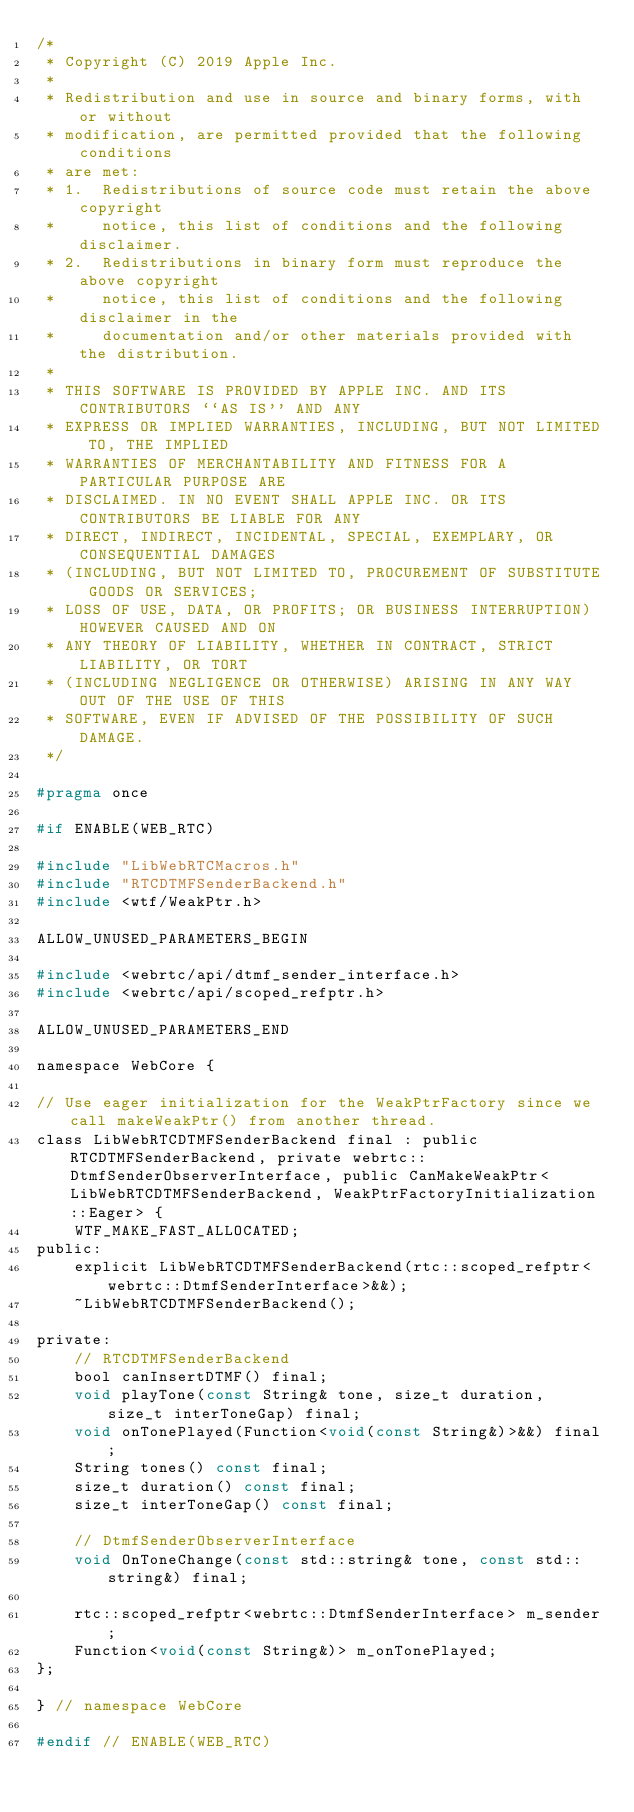<code> <loc_0><loc_0><loc_500><loc_500><_C_>/*
 * Copyright (C) 2019 Apple Inc.
 *
 * Redistribution and use in source and binary forms, with or without
 * modification, are permitted provided that the following conditions
 * are met:
 * 1.  Redistributions of source code must retain the above copyright
 *     notice, this list of conditions and the following disclaimer.
 * 2.  Redistributions in binary form must reproduce the above copyright
 *     notice, this list of conditions and the following disclaimer in the
 *     documentation and/or other materials provided with the distribution.
 *
 * THIS SOFTWARE IS PROVIDED BY APPLE INC. AND ITS CONTRIBUTORS ``AS IS'' AND ANY
 * EXPRESS OR IMPLIED WARRANTIES, INCLUDING, BUT NOT LIMITED TO, THE IMPLIED
 * WARRANTIES OF MERCHANTABILITY AND FITNESS FOR A PARTICULAR PURPOSE ARE
 * DISCLAIMED. IN NO EVENT SHALL APPLE INC. OR ITS CONTRIBUTORS BE LIABLE FOR ANY
 * DIRECT, INDIRECT, INCIDENTAL, SPECIAL, EXEMPLARY, OR CONSEQUENTIAL DAMAGES
 * (INCLUDING, BUT NOT LIMITED TO, PROCUREMENT OF SUBSTITUTE GOODS OR SERVICES;
 * LOSS OF USE, DATA, OR PROFITS; OR BUSINESS INTERRUPTION) HOWEVER CAUSED AND ON
 * ANY THEORY OF LIABILITY, WHETHER IN CONTRACT, STRICT LIABILITY, OR TORT
 * (INCLUDING NEGLIGENCE OR OTHERWISE) ARISING IN ANY WAY OUT OF THE USE OF THIS
 * SOFTWARE, EVEN IF ADVISED OF THE POSSIBILITY OF SUCH DAMAGE.
 */

#pragma once

#if ENABLE(WEB_RTC)

#include "LibWebRTCMacros.h"
#include "RTCDTMFSenderBackend.h"
#include <wtf/WeakPtr.h>

ALLOW_UNUSED_PARAMETERS_BEGIN

#include <webrtc/api/dtmf_sender_interface.h>
#include <webrtc/api/scoped_refptr.h>

ALLOW_UNUSED_PARAMETERS_END

namespace WebCore {

// Use eager initialization for the WeakPtrFactory since we call makeWeakPtr() from another thread.
class LibWebRTCDTMFSenderBackend final : public RTCDTMFSenderBackend, private webrtc::DtmfSenderObserverInterface, public CanMakeWeakPtr<LibWebRTCDTMFSenderBackend, WeakPtrFactoryInitialization::Eager> {
    WTF_MAKE_FAST_ALLOCATED;
public:
    explicit LibWebRTCDTMFSenderBackend(rtc::scoped_refptr<webrtc::DtmfSenderInterface>&&);
    ~LibWebRTCDTMFSenderBackend();

private:
    // RTCDTMFSenderBackend
    bool canInsertDTMF() final;
    void playTone(const String& tone, size_t duration, size_t interToneGap) final;
    void onTonePlayed(Function<void(const String&)>&&) final;
    String tones() const final;
    size_t duration() const final;
    size_t interToneGap() const final;

    // DtmfSenderObserverInterface
    void OnToneChange(const std::string& tone, const std::string&) final;

    rtc::scoped_refptr<webrtc::DtmfSenderInterface> m_sender;
    Function<void(const String&)> m_onTonePlayed;
};

} // namespace WebCore

#endif // ENABLE(WEB_RTC)
</code> 